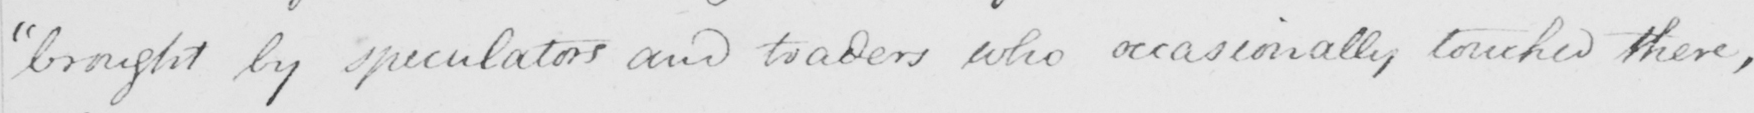Can you read and transcribe this handwriting? brought by speculators and traders who occasionally touched there , 